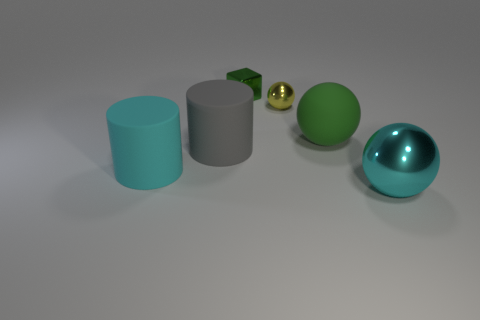Add 3 shiny balls. How many objects exist? 9 Subtract all cylinders. How many objects are left? 4 Add 5 cyan matte things. How many cyan matte things exist? 6 Subtract 0 yellow blocks. How many objects are left? 6 Subtract all small yellow things. Subtract all big cyan shiny spheres. How many objects are left? 4 Add 1 cyan shiny spheres. How many cyan shiny spheres are left? 2 